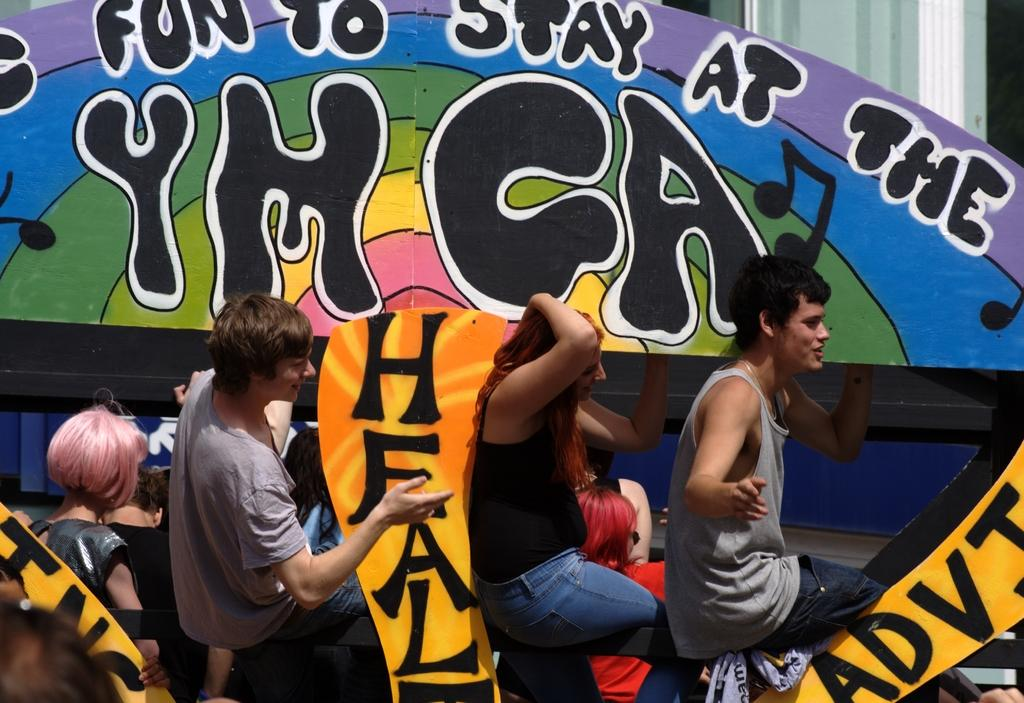How many people can be seen in the image? There are persons visible in the image. What is the background of the image? The persons are in front of a colorful hoarding board. What type of tray is being used by the persons in the image? There is no tray visible in the image. What message does the hoarding board convey about peace? The hoarding board's message about peace cannot be determined from the image, as the content of the board is not described in the provided facts. 